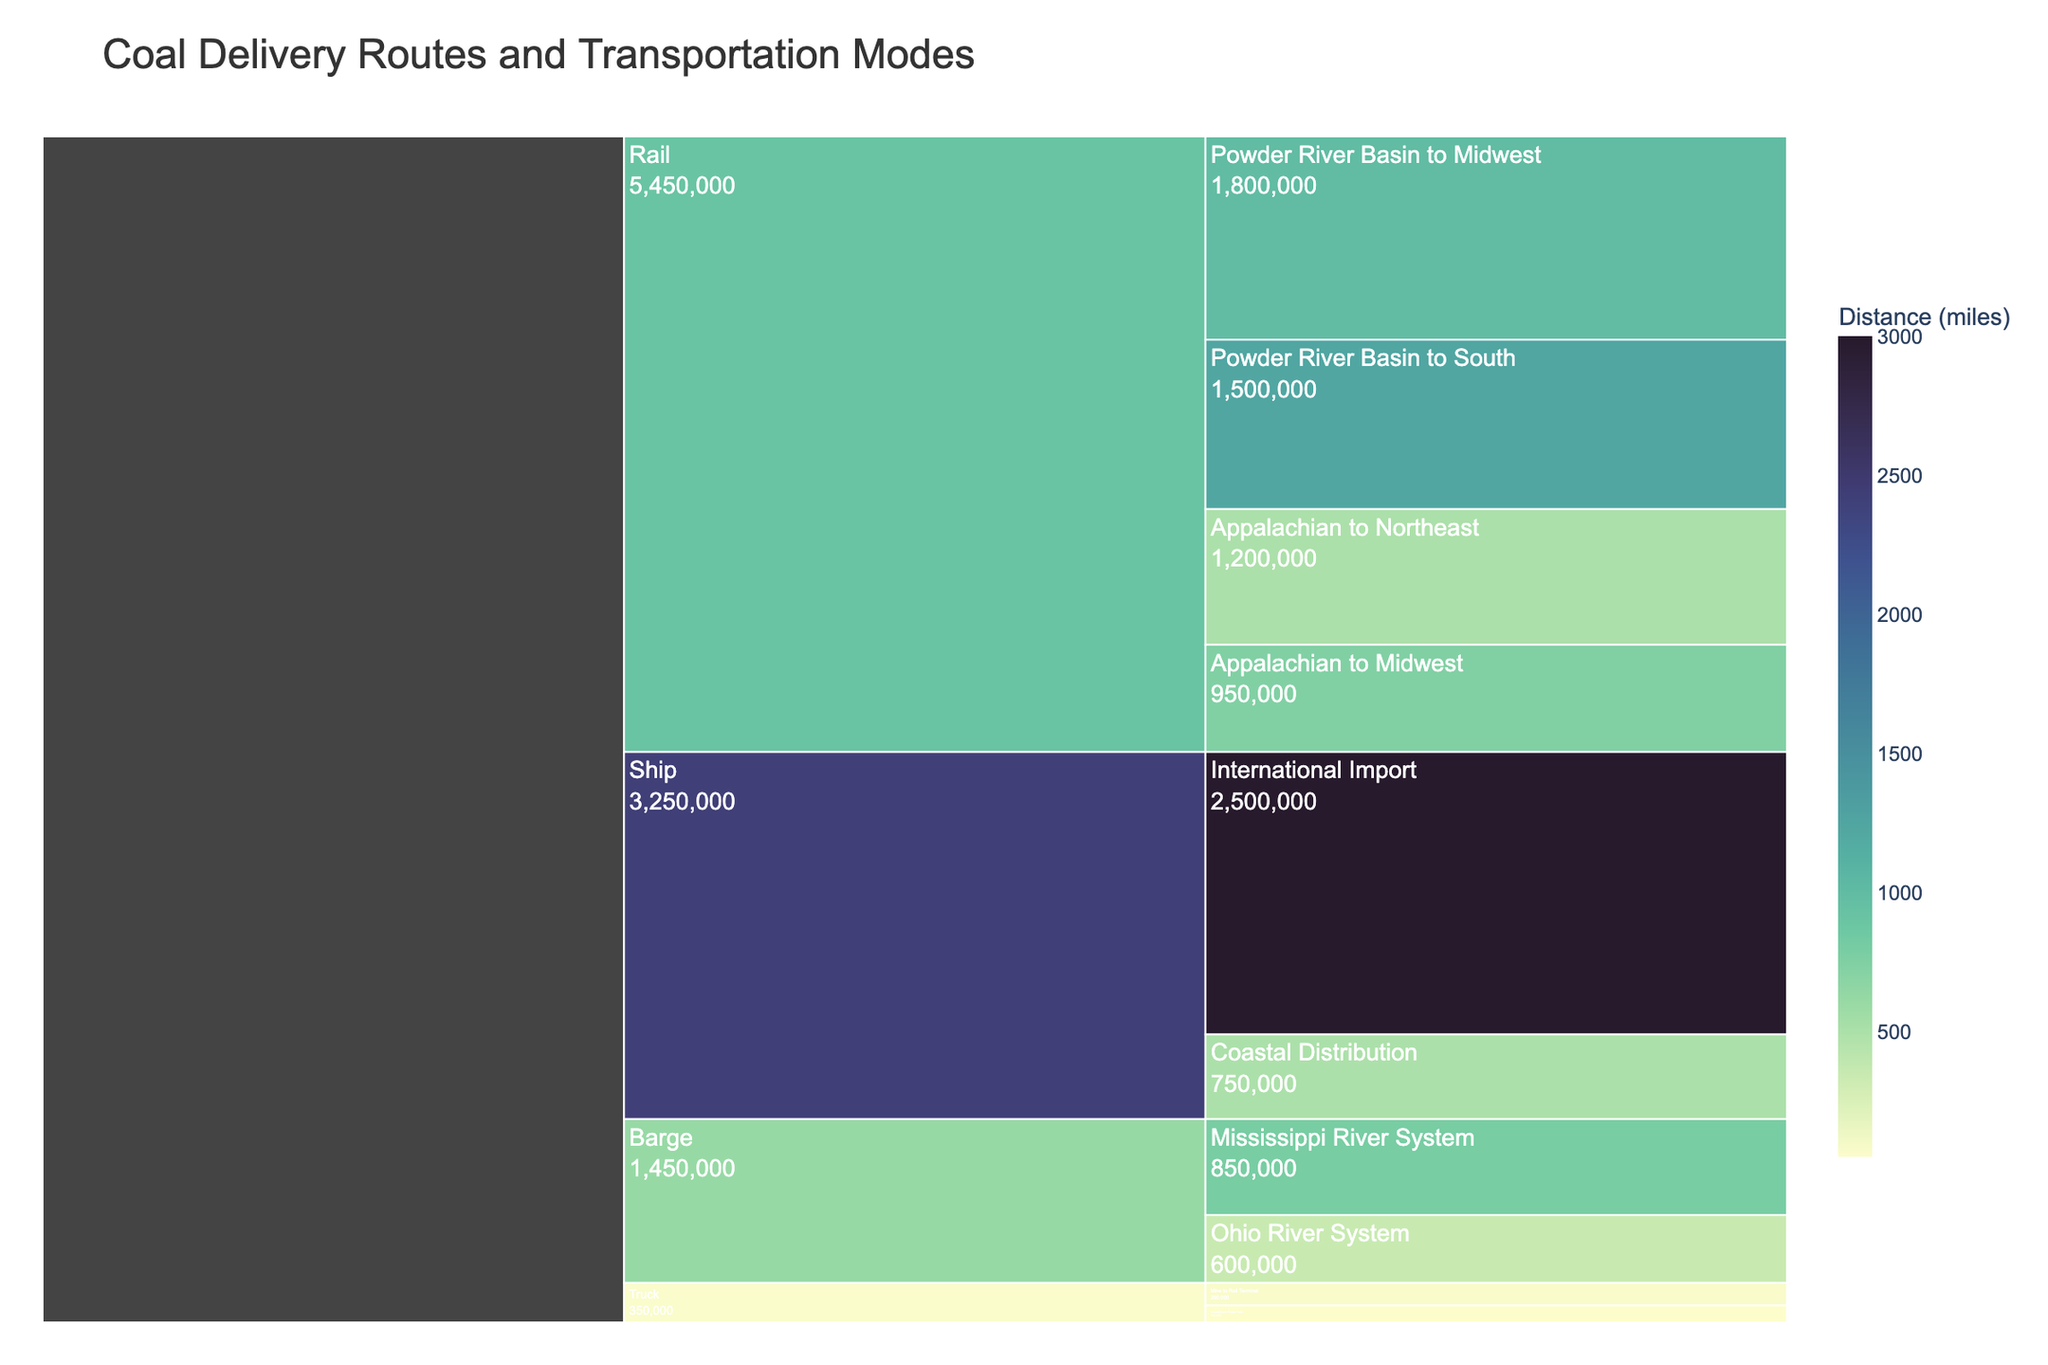What is the title of the Icicle chart? The title is displayed at the top of the chart. Just by looking at the top of the rendered figure, you can read the title.
Answer: Coal Delivery Routes and Transportation Modes What transportation mode has the highest volume of coal transport? By examining the chart, you can see that the largest section with the highest volume is represented by the mode 'Ship' with 'International Import' having 2.5 million tons.
Answer: Ship Which route has the shortest distance? The shortest distance can be identified by looking at the color legend or the labels for the distance. 'Local Mine to Power Plant' under 'Truck' has a distance of 50 miles.
Answer: Local Mine to Power Plant How much total coal volume is transported by rail routes? Add the volumes from all the rail routes: 1,200,000 tons (Appalachian to Northeast) + 950,000 tons (Appalachian to Midwest) + 1,800,000 tons (Powder River Basin to Midwest) + 1,500,000 tons (Powder River Basin to South) = 5,450,000 tons.
Answer: 5,450,000 tons Which has a longer distance: The 'Mississippi River System' using a barge or 'Powder River Basin to South' using rail? By comparing the distances mentioned, 'Mississippi River System' has a distance of 800 miles, whereas 'Powder River Basin to South' has a distance of 1250 miles. Therefore, 'Powder River Basin to South' using rail is longer.
Answer: Powder River Basin to South What is the total volume transported through all the barge routes combined? Sum the volumes from the barge routes: 600,000 tons (Ohio River System) + 850,000 tons (Mississippi River System) = 1,450,000 tons.
Answer: 1,450,000 tons How does the coal volume transported by trucks compare to that by ships? By comparing the values, trucks transport a combined total of 350,000 tons (150,000 + 200,000), while ships transport a combined total of 3,250,000 tons (2,500,000 + 750,000). Clearly, ships transport more coal by volume.
Answer: Ships transport more coal What's the average distance of all the routes transported via rail? To find the average distance, add up all the distances of the rail routes and divide by the number of routes: (500 + 750 + 1000 + 1250) / 4 = 875 miles.
Answer: 875 miles Identify a route that uses a ship and state its volume. One visible route in the chart for ships is 'International Import,' with a volume of 2,500,000 tons.
Answer: International Import, 2,500,000 tons 